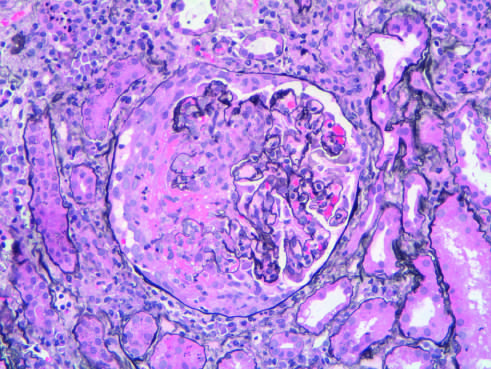s the segmental distribution in this case typical of anca (anti-neutrophil cytoplasmic antibody)- associated crescentic glomerulonephritis?
Answer the question using a single word or phrase. Yes 